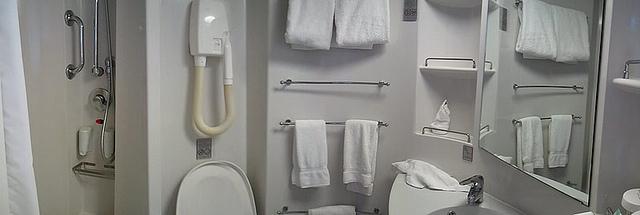Where is the hair dryer?
Quick response, please. Above toilet. How many towels are in this scene?
Short answer required. 5. Is the toilet lid up?
Give a very brief answer. Yes. 